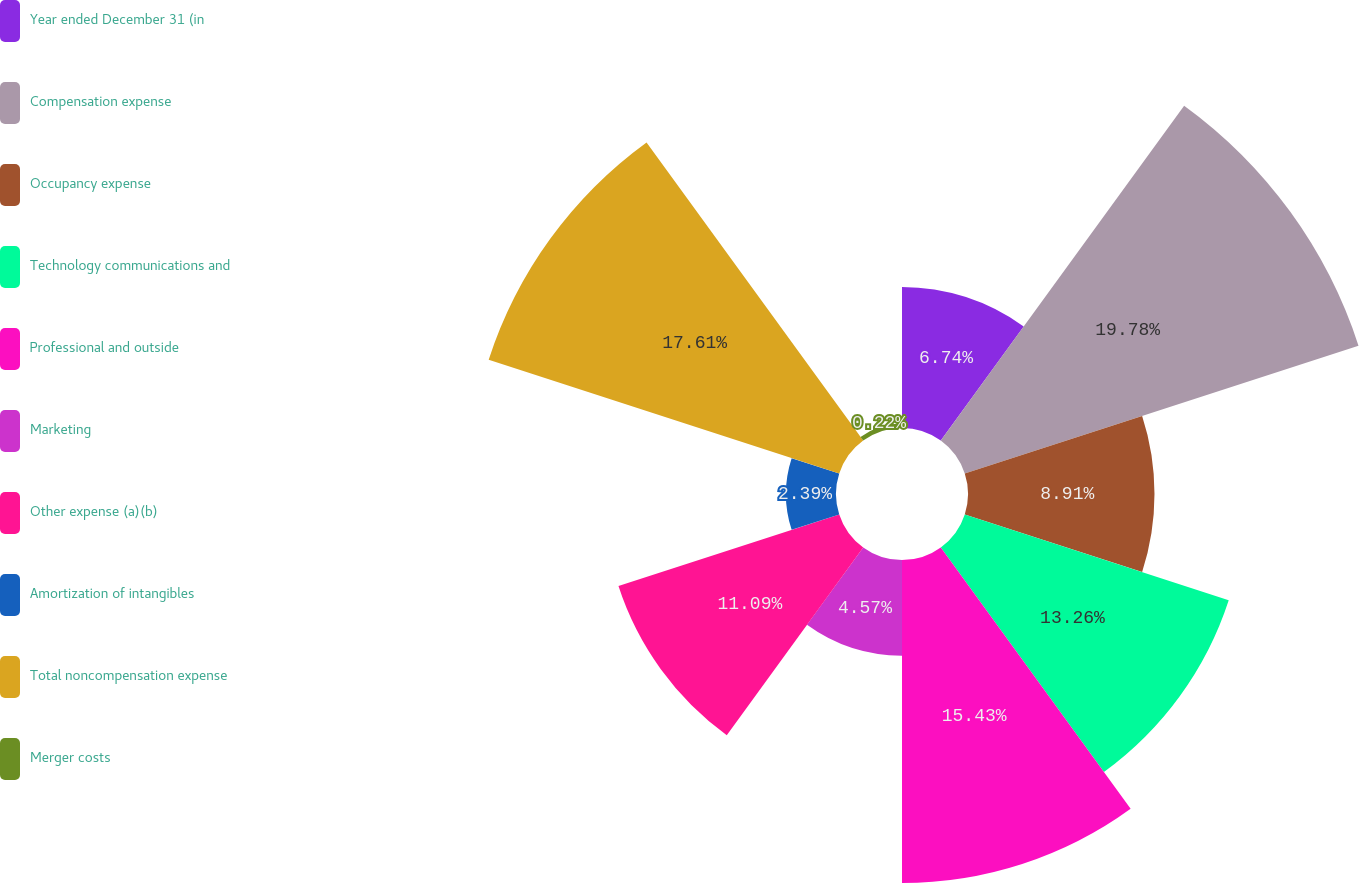<chart> <loc_0><loc_0><loc_500><loc_500><pie_chart><fcel>Year ended December 31 (in<fcel>Compensation expense<fcel>Occupancy expense<fcel>Technology communications and<fcel>Professional and outside<fcel>Marketing<fcel>Other expense (a)(b)<fcel>Amortization of intangibles<fcel>Total noncompensation expense<fcel>Merger costs<nl><fcel>6.74%<fcel>19.78%<fcel>8.91%<fcel>13.26%<fcel>15.43%<fcel>4.57%<fcel>11.09%<fcel>2.39%<fcel>17.61%<fcel>0.22%<nl></chart> 